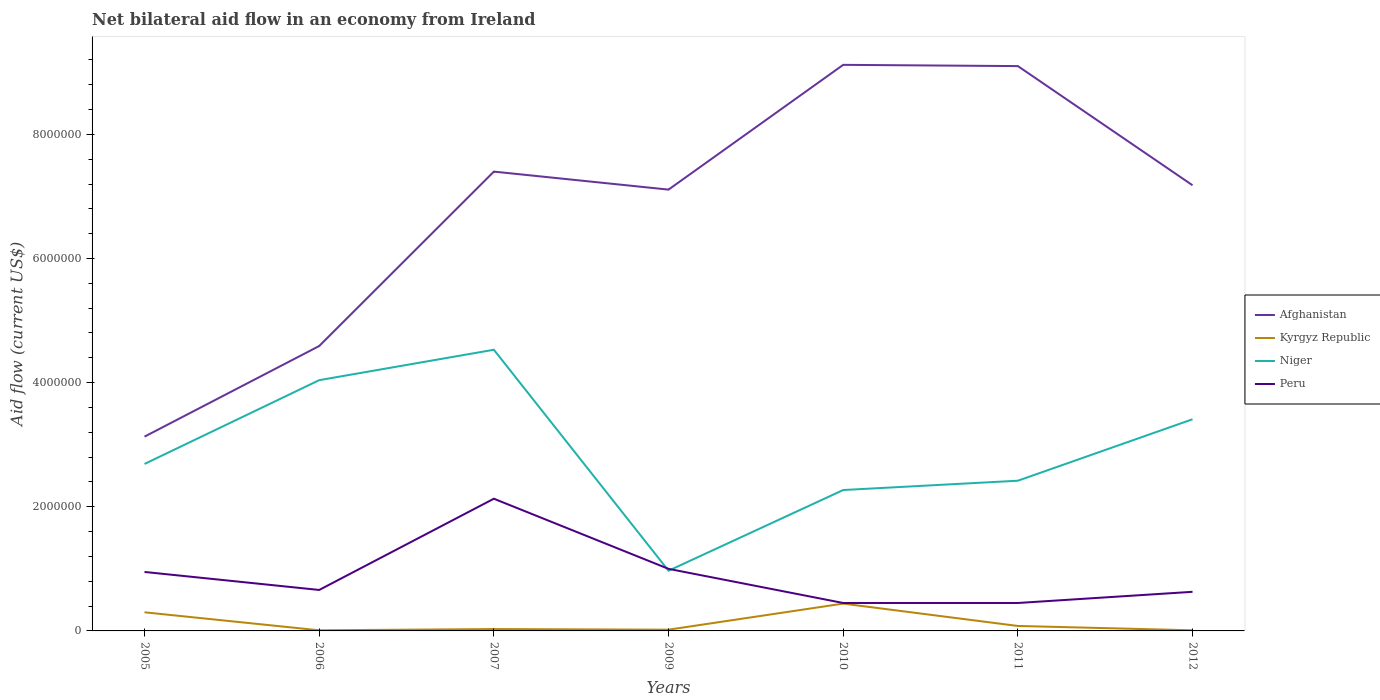How many different coloured lines are there?
Offer a terse response. 4. In which year was the net bilateral aid flow in Afghanistan maximum?
Make the answer very short. 2005. What is the total net bilateral aid flow in Afghanistan in the graph?
Your answer should be compact. 2.20e+05. What is the difference between the highest and the second highest net bilateral aid flow in Kyrgyz Republic?
Ensure brevity in your answer.  4.30e+05. What is the difference between the highest and the lowest net bilateral aid flow in Niger?
Keep it short and to the point. 3. Is the net bilateral aid flow in Niger strictly greater than the net bilateral aid flow in Peru over the years?
Provide a short and direct response. No. How many lines are there?
Your answer should be very brief. 4. How many legend labels are there?
Make the answer very short. 4. What is the title of the graph?
Offer a terse response. Net bilateral aid flow in an economy from Ireland. Does "Dominican Republic" appear as one of the legend labels in the graph?
Give a very brief answer. No. What is the label or title of the X-axis?
Ensure brevity in your answer.  Years. What is the Aid flow (current US$) of Afghanistan in 2005?
Provide a short and direct response. 3.13e+06. What is the Aid flow (current US$) in Kyrgyz Republic in 2005?
Provide a succinct answer. 3.00e+05. What is the Aid flow (current US$) of Niger in 2005?
Ensure brevity in your answer.  2.69e+06. What is the Aid flow (current US$) in Peru in 2005?
Your response must be concise. 9.50e+05. What is the Aid flow (current US$) of Afghanistan in 2006?
Offer a very short reply. 4.59e+06. What is the Aid flow (current US$) of Kyrgyz Republic in 2006?
Offer a terse response. 10000. What is the Aid flow (current US$) of Niger in 2006?
Provide a short and direct response. 4.04e+06. What is the Aid flow (current US$) in Afghanistan in 2007?
Your response must be concise. 7.40e+06. What is the Aid flow (current US$) in Kyrgyz Republic in 2007?
Provide a short and direct response. 3.00e+04. What is the Aid flow (current US$) in Niger in 2007?
Ensure brevity in your answer.  4.53e+06. What is the Aid flow (current US$) in Peru in 2007?
Make the answer very short. 2.13e+06. What is the Aid flow (current US$) in Afghanistan in 2009?
Your answer should be compact. 7.11e+06. What is the Aid flow (current US$) of Kyrgyz Republic in 2009?
Provide a succinct answer. 2.00e+04. What is the Aid flow (current US$) of Niger in 2009?
Your response must be concise. 9.70e+05. What is the Aid flow (current US$) of Peru in 2009?
Give a very brief answer. 1.00e+06. What is the Aid flow (current US$) of Afghanistan in 2010?
Offer a terse response. 9.12e+06. What is the Aid flow (current US$) in Kyrgyz Republic in 2010?
Make the answer very short. 4.40e+05. What is the Aid flow (current US$) in Niger in 2010?
Your answer should be compact. 2.27e+06. What is the Aid flow (current US$) of Peru in 2010?
Offer a very short reply. 4.50e+05. What is the Aid flow (current US$) in Afghanistan in 2011?
Provide a short and direct response. 9.10e+06. What is the Aid flow (current US$) in Kyrgyz Republic in 2011?
Your answer should be very brief. 8.00e+04. What is the Aid flow (current US$) in Niger in 2011?
Ensure brevity in your answer.  2.42e+06. What is the Aid flow (current US$) in Peru in 2011?
Your response must be concise. 4.50e+05. What is the Aid flow (current US$) of Afghanistan in 2012?
Your answer should be compact. 7.18e+06. What is the Aid flow (current US$) of Kyrgyz Republic in 2012?
Provide a succinct answer. 10000. What is the Aid flow (current US$) of Niger in 2012?
Ensure brevity in your answer.  3.41e+06. What is the Aid flow (current US$) of Peru in 2012?
Ensure brevity in your answer.  6.30e+05. Across all years, what is the maximum Aid flow (current US$) of Afghanistan?
Your answer should be very brief. 9.12e+06. Across all years, what is the maximum Aid flow (current US$) in Kyrgyz Republic?
Your answer should be very brief. 4.40e+05. Across all years, what is the maximum Aid flow (current US$) in Niger?
Offer a very short reply. 4.53e+06. Across all years, what is the maximum Aid flow (current US$) in Peru?
Your answer should be compact. 2.13e+06. Across all years, what is the minimum Aid flow (current US$) of Afghanistan?
Your answer should be compact. 3.13e+06. Across all years, what is the minimum Aid flow (current US$) of Niger?
Your response must be concise. 9.70e+05. What is the total Aid flow (current US$) of Afghanistan in the graph?
Keep it short and to the point. 4.76e+07. What is the total Aid flow (current US$) of Kyrgyz Republic in the graph?
Provide a short and direct response. 8.90e+05. What is the total Aid flow (current US$) of Niger in the graph?
Your answer should be compact. 2.03e+07. What is the total Aid flow (current US$) of Peru in the graph?
Make the answer very short. 6.27e+06. What is the difference between the Aid flow (current US$) of Afghanistan in 2005 and that in 2006?
Provide a short and direct response. -1.46e+06. What is the difference between the Aid flow (current US$) in Kyrgyz Republic in 2005 and that in 2006?
Your response must be concise. 2.90e+05. What is the difference between the Aid flow (current US$) in Niger in 2005 and that in 2006?
Your answer should be compact. -1.35e+06. What is the difference between the Aid flow (current US$) in Afghanistan in 2005 and that in 2007?
Your answer should be compact. -4.27e+06. What is the difference between the Aid flow (current US$) of Niger in 2005 and that in 2007?
Your answer should be compact. -1.84e+06. What is the difference between the Aid flow (current US$) in Peru in 2005 and that in 2007?
Your answer should be very brief. -1.18e+06. What is the difference between the Aid flow (current US$) of Afghanistan in 2005 and that in 2009?
Your answer should be compact. -3.98e+06. What is the difference between the Aid flow (current US$) in Niger in 2005 and that in 2009?
Your answer should be compact. 1.72e+06. What is the difference between the Aid flow (current US$) of Afghanistan in 2005 and that in 2010?
Keep it short and to the point. -5.99e+06. What is the difference between the Aid flow (current US$) of Kyrgyz Republic in 2005 and that in 2010?
Your answer should be compact. -1.40e+05. What is the difference between the Aid flow (current US$) in Niger in 2005 and that in 2010?
Make the answer very short. 4.20e+05. What is the difference between the Aid flow (current US$) in Afghanistan in 2005 and that in 2011?
Ensure brevity in your answer.  -5.97e+06. What is the difference between the Aid flow (current US$) in Kyrgyz Republic in 2005 and that in 2011?
Ensure brevity in your answer.  2.20e+05. What is the difference between the Aid flow (current US$) in Niger in 2005 and that in 2011?
Provide a succinct answer. 2.70e+05. What is the difference between the Aid flow (current US$) of Afghanistan in 2005 and that in 2012?
Provide a succinct answer. -4.05e+06. What is the difference between the Aid flow (current US$) of Kyrgyz Republic in 2005 and that in 2012?
Provide a succinct answer. 2.90e+05. What is the difference between the Aid flow (current US$) of Niger in 2005 and that in 2012?
Offer a terse response. -7.20e+05. What is the difference between the Aid flow (current US$) in Peru in 2005 and that in 2012?
Offer a very short reply. 3.20e+05. What is the difference between the Aid flow (current US$) in Afghanistan in 2006 and that in 2007?
Ensure brevity in your answer.  -2.81e+06. What is the difference between the Aid flow (current US$) in Kyrgyz Republic in 2006 and that in 2007?
Offer a terse response. -2.00e+04. What is the difference between the Aid flow (current US$) in Niger in 2006 and that in 2007?
Your answer should be compact. -4.90e+05. What is the difference between the Aid flow (current US$) in Peru in 2006 and that in 2007?
Your answer should be very brief. -1.47e+06. What is the difference between the Aid flow (current US$) in Afghanistan in 2006 and that in 2009?
Ensure brevity in your answer.  -2.52e+06. What is the difference between the Aid flow (current US$) in Niger in 2006 and that in 2009?
Offer a terse response. 3.07e+06. What is the difference between the Aid flow (current US$) in Peru in 2006 and that in 2009?
Your answer should be compact. -3.40e+05. What is the difference between the Aid flow (current US$) in Afghanistan in 2006 and that in 2010?
Your answer should be compact. -4.53e+06. What is the difference between the Aid flow (current US$) of Kyrgyz Republic in 2006 and that in 2010?
Keep it short and to the point. -4.30e+05. What is the difference between the Aid flow (current US$) of Niger in 2006 and that in 2010?
Ensure brevity in your answer.  1.77e+06. What is the difference between the Aid flow (current US$) of Afghanistan in 2006 and that in 2011?
Your answer should be compact. -4.51e+06. What is the difference between the Aid flow (current US$) in Niger in 2006 and that in 2011?
Provide a short and direct response. 1.62e+06. What is the difference between the Aid flow (current US$) of Peru in 2006 and that in 2011?
Ensure brevity in your answer.  2.10e+05. What is the difference between the Aid flow (current US$) of Afghanistan in 2006 and that in 2012?
Your response must be concise. -2.59e+06. What is the difference between the Aid flow (current US$) of Kyrgyz Republic in 2006 and that in 2012?
Offer a very short reply. 0. What is the difference between the Aid flow (current US$) of Niger in 2006 and that in 2012?
Provide a short and direct response. 6.30e+05. What is the difference between the Aid flow (current US$) in Peru in 2006 and that in 2012?
Your answer should be very brief. 3.00e+04. What is the difference between the Aid flow (current US$) of Niger in 2007 and that in 2009?
Your response must be concise. 3.56e+06. What is the difference between the Aid flow (current US$) in Peru in 2007 and that in 2009?
Your response must be concise. 1.13e+06. What is the difference between the Aid flow (current US$) of Afghanistan in 2007 and that in 2010?
Your answer should be very brief. -1.72e+06. What is the difference between the Aid flow (current US$) of Kyrgyz Republic in 2007 and that in 2010?
Your response must be concise. -4.10e+05. What is the difference between the Aid flow (current US$) in Niger in 2007 and that in 2010?
Make the answer very short. 2.26e+06. What is the difference between the Aid flow (current US$) in Peru in 2007 and that in 2010?
Offer a terse response. 1.68e+06. What is the difference between the Aid flow (current US$) of Afghanistan in 2007 and that in 2011?
Give a very brief answer. -1.70e+06. What is the difference between the Aid flow (current US$) in Kyrgyz Republic in 2007 and that in 2011?
Offer a very short reply. -5.00e+04. What is the difference between the Aid flow (current US$) in Niger in 2007 and that in 2011?
Keep it short and to the point. 2.11e+06. What is the difference between the Aid flow (current US$) in Peru in 2007 and that in 2011?
Offer a terse response. 1.68e+06. What is the difference between the Aid flow (current US$) of Kyrgyz Republic in 2007 and that in 2012?
Give a very brief answer. 2.00e+04. What is the difference between the Aid flow (current US$) of Niger in 2007 and that in 2012?
Offer a very short reply. 1.12e+06. What is the difference between the Aid flow (current US$) in Peru in 2007 and that in 2012?
Your answer should be compact. 1.50e+06. What is the difference between the Aid flow (current US$) of Afghanistan in 2009 and that in 2010?
Provide a short and direct response. -2.01e+06. What is the difference between the Aid flow (current US$) of Kyrgyz Republic in 2009 and that in 2010?
Offer a very short reply. -4.20e+05. What is the difference between the Aid flow (current US$) of Niger in 2009 and that in 2010?
Make the answer very short. -1.30e+06. What is the difference between the Aid flow (current US$) in Peru in 2009 and that in 2010?
Your response must be concise. 5.50e+05. What is the difference between the Aid flow (current US$) of Afghanistan in 2009 and that in 2011?
Provide a short and direct response. -1.99e+06. What is the difference between the Aid flow (current US$) in Niger in 2009 and that in 2011?
Provide a short and direct response. -1.45e+06. What is the difference between the Aid flow (current US$) in Peru in 2009 and that in 2011?
Offer a terse response. 5.50e+05. What is the difference between the Aid flow (current US$) in Afghanistan in 2009 and that in 2012?
Your response must be concise. -7.00e+04. What is the difference between the Aid flow (current US$) in Kyrgyz Republic in 2009 and that in 2012?
Offer a very short reply. 10000. What is the difference between the Aid flow (current US$) of Niger in 2009 and that in 2012?
Your response must be concise. -2.44e+06. What is the difference between the Aid flow (current US$) of Peru in 2009 and that in 2012?
Offer a terse response. 3.70e+05. What is the difference between the Aid flow (current US$) in Afghanistan in 2010 and that in 2011?
Your response must be concise. 2.00e+04. What is the difference between the Aid flow (current US$) of Kyrgyz Republic in 2010 and that in 2011?
Make the answer very short. 3.60e+05. What is the difference between the Aid flow (current US$) of Peru in 2010 and that in 2011?
Provide a succinct answer. 0. What is the difference between the Aid flow (current US$) in Afghanistan in 2010 and that in 2012?
Provide a short and direct response. 1.94e+06. What is the difference between the Aid flow (current US$) of Niger in 2010 and that in 2012?
Offer a terse response. -1.14e+06. What is the difference between the Aid flow (current US$) of Peru in 2010 and that in 2012?
Provide a short and direct response. -1.80e+05. What is the difference between the Aid flow (current US$) in Afghanistan in 2011 and that in 2012?
Your answer should be very brief. 1.92e+06. What is the difference between the Aid flow (current US$) in Kyrgyz Republic in 2011 and that in 2012?
Offer a terse response. 7.00e+04. What is the difference between the Aid flow (current US$) of Niger in 2011 and that in 2012?
Your answer should be compact. -9.90e+05. What is the difference between the Aid flow (current US$) in Peru in 2011 and that in 2012?
Your response must be concise. -1.80e+05. What is the difference between the Aid flow (current US$) of Afghanistan in 2005 and the Aid flow (current US$) of Kyrgyz Republic in 2006?
Offer a terse response. 3.12e+06. What is the difference between the Aid flow (current US$) of Afghanistan in 2005 and the Aid flow (current US$) of Niger in 2006?
Offer a very short reply. -9.10e+05. What is the difference between the Aid flow (current US$) in Afghanistan in 2005 and the Aid flow (current US$) in Peru in 2006?
Keep it short and to the point. 2.47e+06. What is the difference between the Aid flow (current US$) of Kyrgyz Republic in 2005 and the Aid flow (current US$) of Niger in 2006?
Offer a terse response. -3.74e+06. What is the difference between the Aid flow (current US$) of Kyrgyz Republic in 2005 and the Aid flow (current US$) of Peru in 2006?
Make the answer very short. -3.60e+05. What is the difference between the Aid flow (current US$) in Niger in 2005 and the Aid flow (current US$) in Peru in 2006?
Your answer should be compact. 2.03e+06. What is the difference between the Aid flow (current US$) in Afghanistan in 2005 and the Aid flow (current US$) in Kyrgyz Republic in 2007?
Provide a short and direct response. 3.10e+06. What is the difference between the Aid flow (current US$) of Afghanistan in 2005 and the Aid flow (current US$) of Niger in 2007?
Your response must be concise. -1.40e+06. What is the difference between the Aid flow (current US$) of Afghanistan in 2005 and the Aid flow (current US$) of Peru in 2007?
Offer a very short reply. 1.00e+06. What is the difference between the Aid flow (current US$) of Kyrgyz Republic in 2005 and the Aid flow (current US$) of Niger in 2007?
Your answer should be compact. -4.23e+06. What is the difference between the Aid flow (current US$) of Kyrgyz Republic in 2005 and the Aid flow (current US$) of Peru in 2007?
Give a very brief answer. -1.83e+06. What is the difference between the Aid flow (current US$) of Niger in 2005 and the Aid flow (current US$) of Peru in 2007?
Your answer should be very brief. 5.60e+05. What is the difference between the Aid flow (current US$) in Afghanistan in 2005 and the Aid flow (current US$) in Kyrgyz Republic in 2009?
Your answer should be compact. 3.11e+06. What is the difference between the Aid flow (current US$) in Afghanistan in 2005 and the Aid flow (current US$) in Niger in 2009?
Keep it short and to the point. 2.16e+06. What is the difference between the Aid flow (current US$) of Afghanistan in 2005 and the Aid flow (current US$) of Peru in 2009?
Provide a short and direct response. 2.13e+06. What is the difference between the Aid flow (current US$) of Kyrgyz Republic in 2005 and the Aid flow (current US$) of Niger in 2009?
Offer a terse response. -6.70e+05. What is the difference between the Aid flow (current US$) of Kyrgyz Republic in 2005 and the Aid flow (current US$) of Peru in 2009?
Give a very brief answer. -7.00e+05. What is the difference between the Aid flow (current US$) of Niger in 2005 and the Aid flow (current US$) of Peru in 2009?
Offer a terse response. 1.69e+06. What is the difference between the Aid flow (current US$) in Afghanistan in 2005 and the Aid flow (current US$) in Kyrgyz Republic in 2010?
Provide a succinct answer. 2.69e+06. What is the difference between the Aid flow (current US$) of Afghanistan in 2005 and the Aid flow (current US$) of Niger in 2010?
Give a very brief answer. 8.60e+05. What is the difference between the Aid flow (current US$) in Afghanistan in 2005 and the Aid flow (current US$) in Peru in 2010?
Keep it short and to the point. 2.68e+06. What is the difference between the Aid flow (current US$) of Kyrgyz Republic in 2005 and the Aid flow (current US$) of Niger in 2010?
Offer a very short reply. -1.97e+06. What is the difference between the Aid flow (current US$) in Niger in 2005 and the Aid flow (current US$) in Peru in 2010?
Make the answer very short. 2.24e+06. What is the difference between the Aid flow (current US$) of Afghanistan in 2005 and the Aid flow (current US$) of Kyrgyz Republic in 2011?
Your response must be concise. 3.05e+06. What is the difference between the Aid flow (current US$) in Afghanistan in 2005 and the Aid flow (current US$) in Niger in 2011?
Offer a terse response. 7.10e+05. What is the difference between the Aid flow (current US$) of Afghanistan in 2005 and the Aid flow (current US$) of Peru in 2011?
Your answer should be compact. 2.68e+06. What is the difference between the Aid flow (current US$) of Kyrgyz Republic in 2005 and the Aid flow (current US$) of Niger in 2011?
Ensure brevity in your answer.  -2.12e+06. What is the difference between the Aid flow (current US$) of Kyrgyz Republic in 2005 and the Aid flow (current US$) of Peru in 2011?
Your answer should be compact. -1.50e+05. What is the difference between the Aid flow (current US$) of Niger in 2005 and the Aid flow (current US$) of Peru in 2011?
Your response must be concise. 2.24e+06. What is the difference between the Aid flow (current US$) in Afghanistan in 2005 and the Aid flow (current US$) in Kyrgyz Republic in 2012?
Make the answer very short. 3.12e+06. What is the difference between the Aid flow (current US$) of Afghanistan in 2005 and the Aid flow (current US$) of Niger in 2012?
Offer a very short reply. -2.80e+05. What is the difference between the Aid flow (current US$) of Afghanistan in 2005 and the Aid flow (current US$) of Peru in 2012?
Make the answer very short. 2.50e+06. What is the difference between the Aid flow (current US$) in Kyrgyz Republic in 2005 and the Aid flow (current US$) in Niger in 2012?
Provide a short and direct response. -3.11e+06. What is the difference between the Aid flow (current US$) in Kyrgyz Republic in 2005 and the Aid flow (current US$) in Peru in 2012?
Your response must be concise. -3.30e+05. What is the difference between the Aid flow (current US$) of Niger in 2005 and the Aid flow (current US$) of Peru in 2012?
Offer a terse response. 2.06e+06. What is the difference between the Aid flow (current US$) in Afghanistan in 2006 and the Aid flow (current US$) in Kyrgyz Republic in 2007?
Provide a short and direct response. 4.56e+06. What is the difference between the Aid flow (current US$) of Afghanistan in 2006 and the Aid flow (current US$) of Peru in 2007?
Give a very brief answer. 2.46e+06. What is the difference between the Aid flow (current US$) in Kyrgyz Republic in 2006 and the Aid flow (current US$) in Niger in 2007?
Provide a succinct answer. -4.52e+06. What is the difference between the Aid flow (current US$) in Kyrgyz Republic in 2006 and the Aid flow (current US$) in Peru in 2007?
Offer a very short reply. -2.12e+06. What is the difference between the Aid flow (current US$) of Niger in 2006 and the Aid flow (current US$) of Peru in 2007?
Give a very brief answer. 1.91e+06. What is the difference between the Aid flow (current US$) of Afghanistan in 2006 and the Aid flow (current US$) of Kyrgyz Republic in 2009?
Provide a succinct answer. 4.57e+06. What is the difference between the Aid flow (current US$) of Afghanistan in 2006 and the Aid flow (current US$) of Niger in 2009?
Give a very brief answer. 3.62e+06. What is the difference between the Aid flow (current US$) in Afghanistan in 2006 and the Aid flow (current US$) in Peru in 2009?
Keep it short and to the point. 3.59e+06. What is the difference between the Aid flow (current US$) in Kyrgyz Republic in 2006 and the Aid flow (current US$) in Niger in 2009?
Give a very brief answer. -9.60e+05. What is the difference between the Aid flow (current US$) in Kyrgyz Republic in 2006 and the Aid flow (current US$) in Peru in 2009?
Offer a very short reply. -9.90e+05. What is the difference between the Aid flow (current US$) in Niger in 2006 and the Aid flow (current US$) in Peru in 2009?
Keep it short and to the point. 3.04e+06. What is the difference between the Aid flow (current US$) of Afghanistan in 2006 and the Aid flow (current US$) of Kyrgyz Republic in 2010?
Your answer should be very brief. 4.15e+06. What is the difference between the Aid flow (current US$) in Afghanistan in 2006 and the Aid flow (current US$) in Niger in 2010?
Ensure brevity in your answer.  2.32e+06. What is the difference between the Aid flow (current US$) of Afghanistan in 2006 and the Aid flow (current US$) of Peru in 2010?
Give a very brief answer. 4.14e+06. What is the difference between the Aid flow (current US$) of Kyrgyz Republic in 2006 and the Aid flow (current US$) of Niger in 2010?
Ensure brevity in your answer.  -2.26e+06. What is the difference between the Aid flow (current US$) of Kyrgyz Republic in 2006 and the Aid flow (current US$) of Peru in 2010?
Provide a succinct answer. -4.40e+05. What is the difference between the Aid flow (current US$) in Niger in 2006 and the Aid flow (current US$) in Peru in 2010?
Keep it short and to the point. 3.59e+06. What is the difference between the Aid flow (current US$) of Afghanistan in 2006 and the Aid flow (current US$) of Kyrgyz Republic in 2011?
Keep it short and to the point. 4.51e+06. What is the difference between the Aid flow (current US$) in Afghanistan in 2006 and the Aid flow (current US$) in Niger in 2011?
Provide a short and direct response. 2.17e+06. What is the difference between the Aid flow (current US$) in Afghanistan in 2006 and the Aid flow (current US$) in Peru in 2011?
Keep it short and to the point. 4.14e+06. What is the difference between the Aid flow (current US$) of Kyrgyz Republic in 2006 and the Aid flow (current US$) of Niger in 2011?
Provide a short and direct response. -2.41e+06. What is the difference between the Aid flow (current US$) in Kyrgyz Republic in 2006 and the Aid flow (current US$) in Peru in 2011?
Your response must be concise. -4.40e+05. What is the difference between the Aid flow (current US$) in Niger in 2006 and the Aid flow (current US$) in Peru in 2011?
Your answer should be compact. 3.59e+06. What is the difference between the Aid flow (current US$) of Afghanistan in 2006 and the Aid flow (current US$) of Kyrgyz Republic in 2012?
Provide a short and direct response. 4.58e+06. What is the difference between the Aid flow (current US$) in Afghanistan in 2006 and the Aid flow (current US$) in Niger in 2012?
Offer a very short reply. 1.18e+06. What is the difference between the Aid flow (current US$) of Afghanistan in 2006 and the Aid flow (current US$) of Peru in 2012?
Ensure brevity in your answer.  3.96e+06. What is the difference between the Aid flow (current US$) of Kyrgyz Republic in 2006 and the Aid flow (current US$) of Niger in 2012?
Offer a very short reply. -3.40e+06. What is the difference between the Aid flow (current US$) in Kyrgyz Republic in 2006 and the Aid flow (current US$) in Peru in 2012?
Keep it short and to the point. -6.20e+05. What is the difference between the Aid flow (current US$) of Niger in 2006 and the Aid flow (current US$) of Peru in 2012?
Your response must be concise. 3.41e+06. What is the difference between the Aid flow (current US$) in Afghanistan in 2007 and the Aid flow (current US$) in Kyrgyz Republic in 2009?
Your answer should be compact. 7.38e+06. What is the difference between the Aid flow (current US$) in Afghanistan in 2007 and the Aid flow (current US$) in Niger in 2009?
Provide a short and direct response. 6.43e+06. What is the difference between the Aid flow (current US$) in Afghanistan in 2007 and the Aid flow (current US$) in Peru in 2009?
Provide a short and direct response. 6.40e+06. What is the difference between the Aid flow (current US$) in Kyrgyz Republic in 2007 and the Aid flow (current US$) in Niger in 2009?
Your response must be concise. -9.40e+05. What is the difference between the Aid flow (current US$) in Kyrgyz Republic in 2007 and the Aid flow (current US$) in Peru in 2009?
Offer a terse response. -9.70e+05. What is the difference between the Aid flow (current US$) in Niger in 2007 and the Aid flow (current US$) in Peru in 2009?
Provide a short and direct response. 3.53e+06. What is the difference between the Aid flow (current US$) of Afghanistan in 2007 and the Aid flow (current US$) of Kyrgyz Republic in 2010?
Offer a very short reply. 6.96e+06. What is the difference between the Aid flow (current US$) in Afghanistan in 2007 and the Aid flow (current US$) in Niger in 2010?
Your answer should be compact. 5.13e+06. What is the difference between the Aid flow (current US$) of Afghanistan in 2007 and the Aid flow (current US$) of Peru in 2010?
Provide a short and direct response. 6.95e+06. What is the difference between the Aid flow (current US$) in Kyrgyz Republic in 2007 and the Aid flow (current US$) in Niger in 2010?
Your response must be concise. -2.24e+06. What is the difference between the Aid flow (current US$) of Kyrgyz Republic in 2007 and the Aid flow (current US$) of Peru in 2010?
Your answer should be very brief. -4.20e+05. What is the difference between the Aid flow (current US$) of Niger in 2007 and the Aid flow (current US$) of Peru in 2010?
Provide a succinct answer. 4.08e+06. What is the difference between the Aid flow (current US$) in Afghanistan in 2007 and the Aid flow (current US$) in Kyrgyz Republic in 2011?
Ensure brevity in your answer.  7.32e+06. What is the difference between the Aid flow (current US$) of Afghanistan in 2007 and the Aid flow (current US$) of Niger in 2011?
Keep it short and to the point. 4.98e+06. What is the difference between the Aid flow (current US$) of Afghanistan in 2007 and the Aid flow (current US$) of Peru in 2011?
Your response must be concise. 6.95e+06. What is the difference between the Aid flow (current US$) in Kyrgyz Republic in 2007 and the Aid flow (current US$) in Niger in 2011?
Ensure brevity in your answer.  -2.39e+06. What is the difference between the Aid flow (current US$) in Kyrgyz Republic in 2007 and the Aid flow (current US$) in Peru in 2011?
Keep it short and to the point. -4.20e+05. What is the difference between the Aid flow (current US$) of Niger in 2007 and the Aid flow (current US$) of Peru in 2011?
Offer a very short reply. 4.08e+06. What is the difference between the Aid flow (current US$) in Afghanistan in 2007 and the Aid flow (current US$) in Kyrgyz Republic in 2012?
Keep it short and to the point. 7.39e+06. What is the difference between the Aid flow (current US$) of Afghanistan in 2007 and the Aid flow (current US$) of Niger in 2012?
Your response must be concise. 3.99e+06. What is the difference between the Aid flow (current US$) in Afghanistan in 2007 and the Aid flow (current US$) in Peru in 2012?
Ensure brevity in your answer.  6.77e+06. What is the difference between the Aid flow (current US$) of Kyrgyz Republic in 2007 and the Aid flow (current US$) of Niger in 2012?
Ensure brevity in your answer.  -3.38e+06. What is the difference between the Aid flow (current US$) of Kyrgyz Republic in 2007 and the Aid flow (current US$) of Peru in 2012?
Keep it short and to the point. -6.00e+05. What is the difference between the Aid flow (current US$) in Niger in 2007 and the Aid flow (current US$) in Peru in 2012?
Provide a succinct answer. 3.90e+06. What is the difference between the Aid flow (current US$) in Afghanistan in 2009 and the Aid flow (current US$) in Kyrgyz Republic in 2010?
Provide a succinct answer. 6.67e+06. What is the difference between the Aid flow (current US$) of Afghanistan in 2009 and the Aid flow (current US$) of Niger in 2010?
Offer a terse response. 4.84e+06. What is the difference between the Aid flow (current US$) in Afghanistan in 2009 and the Aid flow (current US$) in Peru in 2010?
Ensure brevity in your answer.  6.66e+06. What is the difference between the Aid flow (current US$) in Kyrgyz Republic in 2009 and the Aid flow (current US$) in Niger in 2010?
Ensure brevity in your answer.  -2.25e+06. What is the difference between the Aid flow (current US$) of Kyrgyz Republic in 2009 and the Aid flow (current US$) of Peru in 2010?
Offer a terse response. -4.30e+05. What is the difference between the Aid flow (current US$) in Niger in 2009 and the Aid flow (current US$) in Peru in 2010?
Your answer should be very brief. 5.20e+05. What is the difference between the Aid flow (current US$) of Afghanistan in 2009 and the Aid flow (current US$) of Kyrgyz Republic in 2011?
Provide a succinct answer. 7.03e+06. What is the difference between the Aid flow (current US$) of Afghanistan in 2009 and the Aid flow (current US$) of Niger in 2011?
Offer a terse response. 4.69e+06. What is the difference between the Aid flow (current US$) of Afghanistan in 2009 and the Aid flow (current US$) of Peru in 2011?
Your answer should be very brief. 6.66e+06. What is the difference between the Aid flow (current US$) of Kyrgyz Republic in 2009 and the Aid flow (current US$) of Niger in 2011?
Offer a very short reply. -2.40e+06. What is the difference between the Aid flow (current US$) of Kyrgyz Republic in 2009 and the Aid flow (current US$) of Peru in 2011?
Ensure brevity in your answer.  -4.30e+05. What is the difference between the Aid flow (current US$) in Niger in 2009 and the Aid flow (current US$) in Peru in 2011?
Provide a succinct answer. 5.20e+05. What is the difference between the Aid flow (current US$) in Afghanistan in 2009 and the Aid flow (current US$) in Kyrgyz Republic in 2012?
Your response must be concise. 7.10e+06. What is the difference between the Aid flow (current US$) in Afghanistan in 2009 and the Aid flow (current US$) in Niger in 2012?
Provide a short and direct response. 3.70e+06. What is the difference between the Aid flow (current US$) in Afghanistan in 2009 and the Aid flow (current US$) in Peru in 2012?
Offer a very short reply. 6.48e+06. What is the difference between the Aid flow (current US$) of Kyrgyz Republic in 2009 and the Aid flow (current US$) of Niger in 2012?
Make the answer very short. -3.39e+06. What is the difference between the Aid flow (current US$) in Kyrgyz Republic in 2009 and the Aid flow (current US$) in Peru in 2012?
Provide a succinct answer. -6.10e+05. What is the difference between the Aid flow (current US$) in Afghanistan in 2010 and the Aid flow (current US$) in Kyrgyz Republic in 2011?
Provide a succinct answer. 9.04e+06. What is the difference between the Aid flow (current US$) in Afghanistan in 2010 and the Aid flow (current US$) in Niger in 2011?
Offer a very short reply. 6.70e+06. What is the difference between the Aid flow (current US$) of Afghanistan in 2010 and the Aid flow (current US$) of Peru in 2011?
Your response must be concise. 8.67e+06. What is the difference between the Aid flow (current US$) of Kyrgyz Republic in 2010 and the Aid flow (current US$) of Niger in 2011?
Keep it short and to the point. -1.98e+06. What is the difference between the Aid flow (current US$) of Niger in 2010 and the Aid flow (current US$) of Peru in 2011?
Provide a succinct answer. 1.82e+06. What is the difference between the Aid flow (current US$) of Afghanistan in 2010 and the Aid flow (current US$) of Kyrgyz Republic in 2012?
Make the answer very short. 9.11e+06. What is the difference between the Aid flow (current US$) in Afghanistan in 2010 and the Aid flow (current US$) in Niger in 2012?
Give a very brief answer. 5.71e+06. What is the difference between the Aid flow (current US$) in Afghanistan in 2010 and the Aid flow (current US$) in Peru in 2012?
Your answer should be compact. 8.49e+06. What is the difference between the Aid flow (current US$) in Kyrgyz Republic in 2010 and the Aid flow (current US$) in Niger in 2012?
Provide a short and direct response. -2.97e+06. What is the difference between the Aid flow (current US$) of Kyrgyz Republic in 2010 and the Aid flow (current US$) of Peru in 2012?
Your answer should be compact. -1.90e+05. What is the difference between the Aid flow (current US$) of Niger in 2010 and the Aid flow (current US$) of Peru in 2012?
Offer a terse response. 1.64e+06. What is the difference between the Aid flow (current US$) of Afghanistan in 2011 and the Aid flow (current US$) of Kyrgyz Republic in 2012?
Your answer should be very brief. 9.09e+06. What is the difference between the Aid flow (current US$) of Afghanistan in 2011 and the Aid flow (current US$) of Niger in 2012?
Your answer should be compact. 5.69e+06. What is the difference between the Aid flow (current US$) of Afghanistan in 2011 and the Aid flow (current US$) of Peru in 2012?
Give a very brief answer. 8.47e+06. What is the difference between the Aid flow (current US$) in Kyrgyz Republic in 2011 and the Aid flow (current US$) in Niger in 2012?
Provide a succinct answer. -3.33e+06. What is the difference between the Aid flow (current US$) of Kyrgyz Republic in 2011 and the Aid flow (current US$) of Peru in 2012?
Your response must be concise. -5.50e+05. What is the difference between the Aid flow (current US$) in Niger in 2011 and the Aid flow (current US$) in Peru in 2012?
Your response must be concise. 1.79e+06. What is the average Aid flow (current US$) of Afghanistan per year?
Keep it short and to the point. 6.80e+06. What is the average Aid flow (current US$) of Kyrgyz Republic per year?
Provide a succinct answer. 1.27e+05. What is the average Aid flow (current US$) of Niger per year?
Provide a succinct answer. 2.90e+06. What is the average Aid flow (current US$) in Peru per year?
Offer a very short reply. 8.96e+05. In the year 2005, what is the difference between the Aid flow (current US$) in Afghanistan and Aid flow (current US$) in Kyrgyz Republic?
Provide a succinct answer. 2.83e+06. In the year 2005, what is the difference between the Aid flow (current US$) in Afghanistan and Aid flow (current US$) in Peru?
Ensure brevity in your answer.  2.18e+06. In the year 2005, what is the difference between the Aid flow (current US$) in Kyrgyz Republic and Aid flow (current US$) in Niger?
Your answer should be very brief. -2.39e+06. In the year 2005, what is the difference between the Aid flow (current US$) in Kyrgyz Republic and Aid flow (current US$) in Peru?
Your response must be concise. -6.50e+05. In the year 2005, what is the difference between the Aid flow (current US$) in Niger and Aid flow (current US$) in Peru?
Provide a short and direct response. 1.74e+06. In the year 2006, what is the difference between the Aid flow (current US$) in Afghanistan and Aid flow (current US$) in Kyrgyz Republic?
Offer a very short reply. 4.58e+06. In the year 2006, what is the difference between the Aid flow (current US$) of Afghanistan and Aid flow (current US$) of Niger?
Make the answer very short. 5.50e+05. In the year 2006, what is the difference between the Aid flow (current US$) of Afghanistan and Aid flow (current US$) of Peru?
Keep it short and to the point. 3.93e+06. In the year 2006, what is the difference between the Aid flow (current US$) of Kyrgyz Republic and Aid flow (current US$) of Niger?
Keep it short and to the point. -4.03e+06. In the year 2006, what is the difference between the Aid flow (current US$) of Kyrgyz Republic and Aid flow (current US$) of Peru?
Your response must be concise. -6.50e+05. In the year 2006, what is the difference between the Aid flow (current US$) of Niger and Aid flow (current US$) of Peru?
Keep it short and to the point. 3.38e+06. In the year 2007, what is the difference between the Aid flow (current US$) in Afghanistan and Aid flow (current US$) in Kyrgyz Republic?
Keep it short and to the point. 7.37e+06. In the year 2007, what is the difference between the Aid flow (current US$) of Afghanistan and Aid flow (current US$) of Niger?
Offer a terse response. 2.87e+06. In the year 2007, what is the difference between the Aid flow (current US$) of Afghanistan and Aid flow (current US$) of Peru?
Offer a terse response. 5.27e+06. In the year 2007, what is the difference between the Aid flow (current US$) of Kyrgyz Republic and Aid flow (current US$) of Niger?
Make the answer very short. -4.50e+06. In the year 2007, what is the difference between the Aid flow (current US$) of Kyrgyz Republic and Aid flow (current US$) of Peru?
Your answer should be very brief. -2.10e+06. In the year 2007, what is the difference between the Aid flow (current US$) of Niger and Aid flow (current US$) of Peru?
Offer a terse response. 2.40e+06. In the year 2009, what is the difference between the Aid flow (current US$) of Afghanistan and Aid flow (current US$) of Kyrgyz Republic?
Provide a short and direct response. 7.09e+06. In the year 2009, what is the difference between the Aid flow (current US$) of Afghanistan and Aid flow (current US$) of Niger?
Offer a very short reply. 6.14e+06. In the year 2009, what is the difference between the Aid flow (current US$) of Afghanistan and Aid flow (current US$) of Peru?
Your response must be concise. 6.11e+06. In the year 2009, what is the difference between the Aid flow (current US$) of Kyrgyz Republic and Aid flow (current US$) of Niger?
Offer a very short reply. -9.50e+05. In the year 2009, what is the difference between the Aid flow (current US$) of Kyrgyz Republic and Aid flow (current US$) of Peru?
Give a very brief answer. -9.80e+05. In the year 2009, what is the difference between the Aid flow (current US$) in Niger and Aid flow (current US$) in Peru?
Make the answer very short. -3.00e+04. In the year 2010, what is the difference between the Aid flow (current US$) of Afghanistan and Aid flow (current US$) of Kyrgyz Republic?
Keep it short and to the point. 8.68e+06. In the year 2010, what is the difference between the Aid flow (current US$) in Afghanistan and Aid flow (current US$) in Niger?
Your answer should be compact. 6.85e+06. In the year 2010, what is the difference between the Aid flow (current US$) of Afghanistan and Aid flow (current US$) of Peru?
Make the answer very short. 8.67e+06. In the year 2010, what is the difference between the Aid flow (current US$) in Kyrgyz Republic and Aid flow (current US$) in Niger?
Provide a succinct answer. -1.83e+06. In the year 2010, what is the difference between the Aid flow (current US$) of Kyrgyz Republic and Aid flow (current US$) of Peru?
Your response must be concise. -10000. In the year 2010, what is the difference between the Aid flow (current US$) in Niger and Aid flow (current US$) in Peru?
Your response must be concise. 1.82e+06. In the year 2011, what is the difference between the Aid flow (current US$) of Afghanistan and Aid flow (current US$) of Kyrgyz Republic?
Provide a short and direct response. 9.02e+06. In the year 2011, what is the difference between the Aid flow (current US$) of Afghanistan and Aid flow (current US$) of Niger?
Provide a succinct answer. 6.68e+06. In the year 2011, what is the difference between the Aid flow (current US$) of Afghanistan and Aid flow (current US$) of Peru?
Your answer should be very brief. 8.65e+06. In the year 2011, what is the difference between the Aid flow (current US$) of Kyrgyz Republic and Aid flow (current US$) of Niger?
Provide a succinct answer. -2.34e+06. In the year 2011, what is the difference between the Aid flow (current US$) of Kyrgyz Republic and Aid flow (current US$) of Peru?
Make the answer very short. -3.70e+05. In the year 2011, what is the difference between the Aid flow (current US$) of Niger and Aid flow (current US$) of Peru?
Offer a very short reply. 1.97e+06. In the year 2012, what is the difference between the Aid flow (current US$) of Afghanistan and Aid flow (current US$) of Kyrgyz Republic?
Provide a short and direct response. 7.17e+06. In the year 2012, what is the difference between the Aid flow (current US$) in Afghanistan and Aid flow (current US$) in Niger?
Your answer should be compact. 3.77e+06. In the year 2012, what is the difference between the Aid flow (current US$) in Afghanistan and Aid flow (current US$) in Peru?
Give a very brief answer. 6.55e+06. In the year 2012, what is the difference between the Aid flow (current US$) in Kyrgyz Republic and Aid flow (current US$) in Niger?
Your answer should be very brief. -3.40e+06. In the year 2012, what is the difference between the Aid flow (current US$) of Kyrgyz Republic and Aid flow (current US$) of Peru?
Provide a short and direct response. -6.20e+05. In the year 2012, what is the difference between the Aid flow (current US$) of Niger and Aid flow (current US$) of Peru?
Give a very brief answer. 2.78e+06. What is the ratio of the Aid flow (current US$) in Afghanistan in 2005 to that in 2006?
Your response must be concise. 0.68. What is the ratio of the Aid flow (current US$) in Niger in 2005 to that in 2006?
Offer a very short reply. 0.67. What is the ratio of the Aid flow (current US$) in Peru in 2005 to that in 2006?
Your answer should be very brief. 1.44. What is the ratio of the Aid flow (current US$) of Afghanistan in 2005 to that in 2007?
Ensure brevity in your answer.  0.42. What is the ratio of the Aid flow (current US$) in Kyrgyz Republic in 2005 to that in 2007?
Give a very brief answer. 10. What is the ratio of the Aid flow (current US$) of Niger in 2005 to that in 2007?
Provide a succinct answer. 0.59. What is the ratio of the Aid flow (current US$) in Peru in 2005 to that in 2007?
Your response must be concise. 0.45. What is the ratio of the Aid flow (current US$) of Afghanistan in 2005 to that in 2009?
Provide a short and direct response. 0.44. What is the ratio of the Aid flow (current US$) of Niger in 2005 to that in 2009?
Your response must be concise. 2.77. What is the ratio of the Aid flow (current US$) of Afghanistan in 2005 to that in 2010?
Provide a short and direct response. 0.34. What is the ratio of the Aid flow (current US$) in Kyrgyz Republic in 2005 to that in 2010?
Ensure brevity in your answer.  0.68. What is the ratio of the Aid flow (current US$) of Niger in 2005 to that in 2010?
Provide a short and direct response. 1.19. What is the ratio of the Aid flow (current US$) in Peru in 2005 to that in 2010?
Keep it short and to the point. 2.11. What is the ratio of the Aid flow (current US$) of Afghanistan in 2005 to that in 2011?
Your response must be concise. 0.34. What is the ratio of the Aid flow (current US$) of Kyrgyz Republic in 2005 to that in 2011?
Offer a very short reply. 3.75. What is the ratio of the Aid flow (current US$) of Niger in 2005 to that in 2011?
Give a very brief answer. 1.11. What is the ratio of the Aid flow (current US$) in Peru in 2005 to that in 2011?
Provide a succinct answer. 2.11. What is the ratio of the Aid flow (current US$) of Afghanistan in 2005 to that in 2012?
Your response must be concise. 0.44. What is the ratio of the Aid flow (current US$) of Niger in 2005 to that in 2012?
Offer a very short reply. 0.79. What is the ratio of the Aid flow (current US$) of Peru in 2005 to that in 2012?
Provide a succinct answer. 1.51. What is the ratio of the Aid flow (current US$) in Afghanistan in 2006 to that in 2007?
Offer a very short reply. 0.62. What is the ratio of the Aid flow (current US$) of Kyrgyz Republic in 2006 to that in 2007?
Provide a succinct answer. 0.33. What is the ratio of the Aid flow (current US$) in Niger in 2006 to that in 2007?
Offer a very short reply. 0.89. What is the ratio of the Aid flow (current US$) in Peru in 2006 to that in 2007?
Offer a terse response. 0.31. What is the ratio of the Aid flow (current US$) in Afghanistan in 2006 to that in 2009?
Make the answer very short. 0.65. What is the ratio of the Aid flow (current US$) in Kyrgyz Republic in 2006 to that in 2009?
Offer a very short reply. 0.5. What is the ratio of the Aid flow (current US$) in Niger in 2006 to that in 2009?
Make the answer very short. 4.16. What is the ratio of the Aid flow (current US$) in Peru in 2006 to that in 2009?
Offer a very short reply. 0.66. What is the ratio of the Aid flow (current US$) in Afghanistan in 2006 to that in 2010?
Your answer should be very brief. 0.5. What is the ratio of the Aid flow (current US$) in Kyrgyz Republic in 2006 to that in 2010?
Your response must be concise. 0.02. What is the ratio of the Aid flow (current US$) in Niger in 2006 to that in 2010?
Offer a very short reply. 1.78. What is the ratio of the Aid flow (current US$) of Peru in 2006 to that in 2010?
Give a very brief answer. 1.47. What is the ratio of the Aid flow (current US$) in Afghanistan in 2006 to that in 2011?
Your answer should be very brief. 0.5. What is the ratio of the Aid flow (current US$) of Kyrgyz Republic in 2006 to that in 2011?
Make the answer very short. 0.12. What is the ratio of the Aid flow (current US$) of Niger in 2006 to that in 2011?
Offer a very short reply. 1.67. What is the ratio of the Aid flow (current US$) in Peru in 2006 to that in 2011?
Your answer should be compact. 1.47. What is the ratio of the Aid flow (current US$) in Afghanistan in 2006 to that in 2012?
Make the answer very short. 0.64. What is the ratio of the Aid flow (current US$) in Niger in 2006 to that in 2012?
Offer a very short reply. 1.18. What is the ratio of the Aid flow (current US$) in Peru in 2006 to that in 2012?
Offer a very short reply. 1.05. What is the ratio of the Aid flow (current US$) in Afghanistan in 2007 to that in 2009?
Ensure brevity in your answer.  1.04. What is the ratio of the Aid flow (current US$) of Niger in 2007 to that in 2009?
Your response must be concise. 4.67. What is the ratio of the Aid flow (current US$) in Peru in 2007 to that in 2009?
Give a very brief answer. 2.13. What is the ratio of the Aid flow (current US$) of Afghanistan in 2007 to that in 2010?
Provide a short and direct response. 0.81. What is the ratio of the Aid flow (current US$) of Kyrgyz Republic in 2007 to that in 2010?
Your answer should be very brief. 0.07. What is the ratio of the Aid flow (current US$) of Niger in 2007 to that in 2010?
Offer a very short reply. 2. What is the ratio of the Aid flow (current US$) of Peru in 2007 to that in 2010?
Give a very brief answer. 4.73. What is the ratio of the Aid flow (current US$) in Afghanistan in 2007 to that in 2011?
Provide a succinct answer. 0.81. What is the ratio of the Aid flow (current US$) of Niger in 2007 to that in 2011?
Offer a very short reply. 1.87. What is the ratio of the Aid flow (current US$) in Peru in 2007 to that in 2011?
Your response must be concise. 4.73. What is the ratio of the Aid flow (current US$) of Afghanistan in 2007 to that in 2012?
Keep it short and to the point. 1.03. What is the ratio of the Aid flow (current US$) in Kyrgyz Republic in 2007 to that in 2012?
Your answer should be compact. 3. What is the ratio of the Aid flow (current US$) of Niger in 2007 to that in 2012?
Give a very brief answer. 1.33. What is the ratio of the Aid flow (current US$) of Peru in 2007 to that in 2012?
Provide a short and direct response. 3.38. What is the ratio of the Aid flow (current US$) in Afghanistan in 2009 to that in 2010?
Provide a short and direct response. 0.78. What is the ratio of the Aid flow (current US$) in Kyrgyz Republic in 2009 to that in 2010?
Offer a very short reply. 0.05. What is the ratio of the Aid flow (current US$) of Niger in 2009 to that in 2010?
Offer a very short reply. 0.43. What is the ratio of the Aid flow (current US$) in Peru in 2009 to that in 2010?
Keep it short and to the point. 2.22. What is the ratio of the Aid flow (current US$) in Afghanistan in 2009 to that in 2011?
Provide a succinct answer. 0.78. What is the ratio of the Aid flow (current US$) in Kyrgyz Republic in 2009 to that in 2011?
Offer a very short reply. 0.25. What is the ratio of the Aid flow (current US$) of Niger in 2009 to that in 2011?
Provide a short and direct response. 0.4. What is the ratio of the Aid flow (current US$) in Peru in 2009 to that in 2011?
Offer a very short reply. 2.22. What is the ratio of the Aid flow (current US$) in Afghanistan in 2009 to that in 2012?
Your response must be concise. 0.99. What is the ratio of the Aid flow (current US$) of Kyrgyz Republic in 2009 to that in 2012?
Make the answer very short. 2. What is the ratio of the Aid flow (current US$) of Niger in 2009 to that in 2012?
Your response must be concise. 0.28. What is the ratio of the Aid flow (current US$) of Peru in 2009 to that in 2012?
Offer a terse response. 1.59. What is the ratio of the Aid flow (current US$) in Kyrgyz Republic in 2010 to that in 2011?
Your answer should be compact. 5.5. What is the ratio of the Aid flow (current US$) of Niger in 2010 to that in 2011?
Provide a short and direct response. 0.94. What is the ratio of the Aid flow (current US$) of Afghanistan in 2010 to that in 2012?
Offer a terse response. 1.27. What is the ratio of the Aid flow (current US$) in Niger in 2010 to that in 2012?
Keep it short and to the point. 0.67. What is the ratio of the Aid flow (current US$) of Peru in 2010 to that in 2012?
Ensure brevity in your answer.  0.71. What is the ratio of the Aid flow (current US$) in Afghanistan in 2011 to that in 2012?
Your response must be concise. 1.27. What is the ratio of the Aid flow (current US$) in Niger in 2011 to that in 2012?
Your answer should be compact. 0.71. What is the ratio of the Aid flow (current US$) in Peru in 2011 to that in 2012?
Offer a terse response. 0.71. What is the difference between the highest and the second highest Aid flow (current US$) of Niger?
Keep it short and to the point. 4.90e+05. What is the difference between the highest and the second highest Aid flow (current US$) of Peru?
Ensure brevity in your answer.  1.13e+06. What is the difference between the highest and the lowest Aid flow (current US$) in Afghanistan?
Provide a short and direct response. 5.99e+06. What is the difference between the highest and the lowest Aid flow (current US$) of Kyrgyz Republic?
Provide a short and direct response. 4.30e+05. What is the difference between the highest and the lowest Aid flow (current US$) of Niger?
Ensure brevity in your answer.  3.56e+06. What is the difference between the highest and the lowest Aid flow (current US$) of Peru?
Provide a succinct answer. 1.68e+06. 